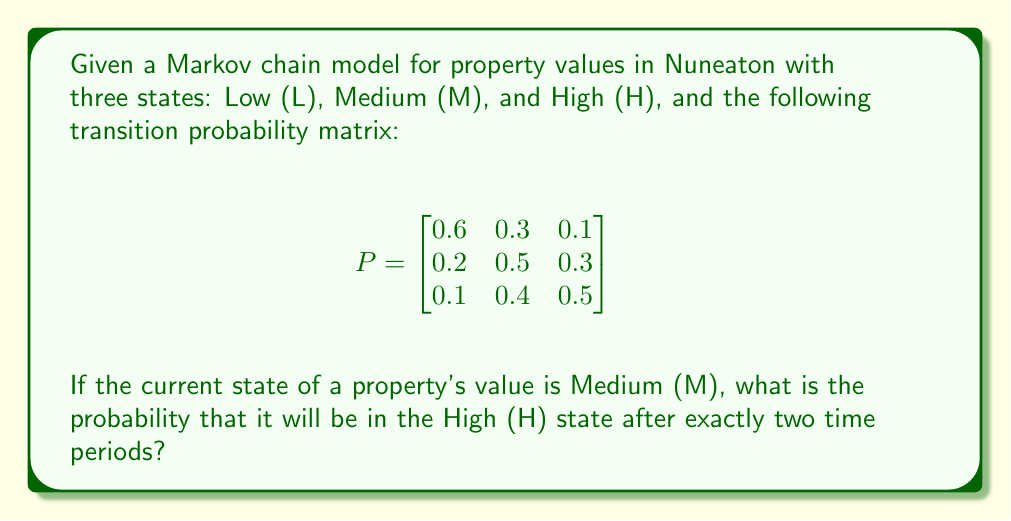Solve this math problem. To solve this problem, we need to use the Chapman-Kolmogorov equations and the given transition probability matrix. Let's follow these steps:

1) The initial state is Medium (M), which corresponds to the second row of the transition matrix.

2) We need to calculate the two-step transition probability from M to H. This can be done by squaring the transition matrix:

   $$P^2 = P \times P = \begin{bmatrix}
   0.6 & 0.3 & 0.1 \\
   0.2 & 0.5 & 0.3 \\
   0.1 & 0.4 & 0.5
   \end{bmatrix} \times \begin{bmatrix}
   0.6 & 0.3 & 0.1 \\
   0.2 & 0.5 & 0.3 \\
   0.1 & 0.4 & 0.5
   \end{bmatrix}$$

3) Performing the matrix multiplication:

   $$P^2 = \begin{bmatrix}
   0.42 & 0.39 & 0.19 \\
   0.25 & 0.46 & 0.29 \\
   0.21 & 0.44 & 0.35
   \end{bmatrix}$$

4) The probability we're looking for is the entry in the second row (because we start in state M) and third column (because we want to end in state H) of $P^2$.

5) Therefore, the probability of transitioning from M to H in exactly two time periods is 0.29 or 29%.
Answer: 0.29 